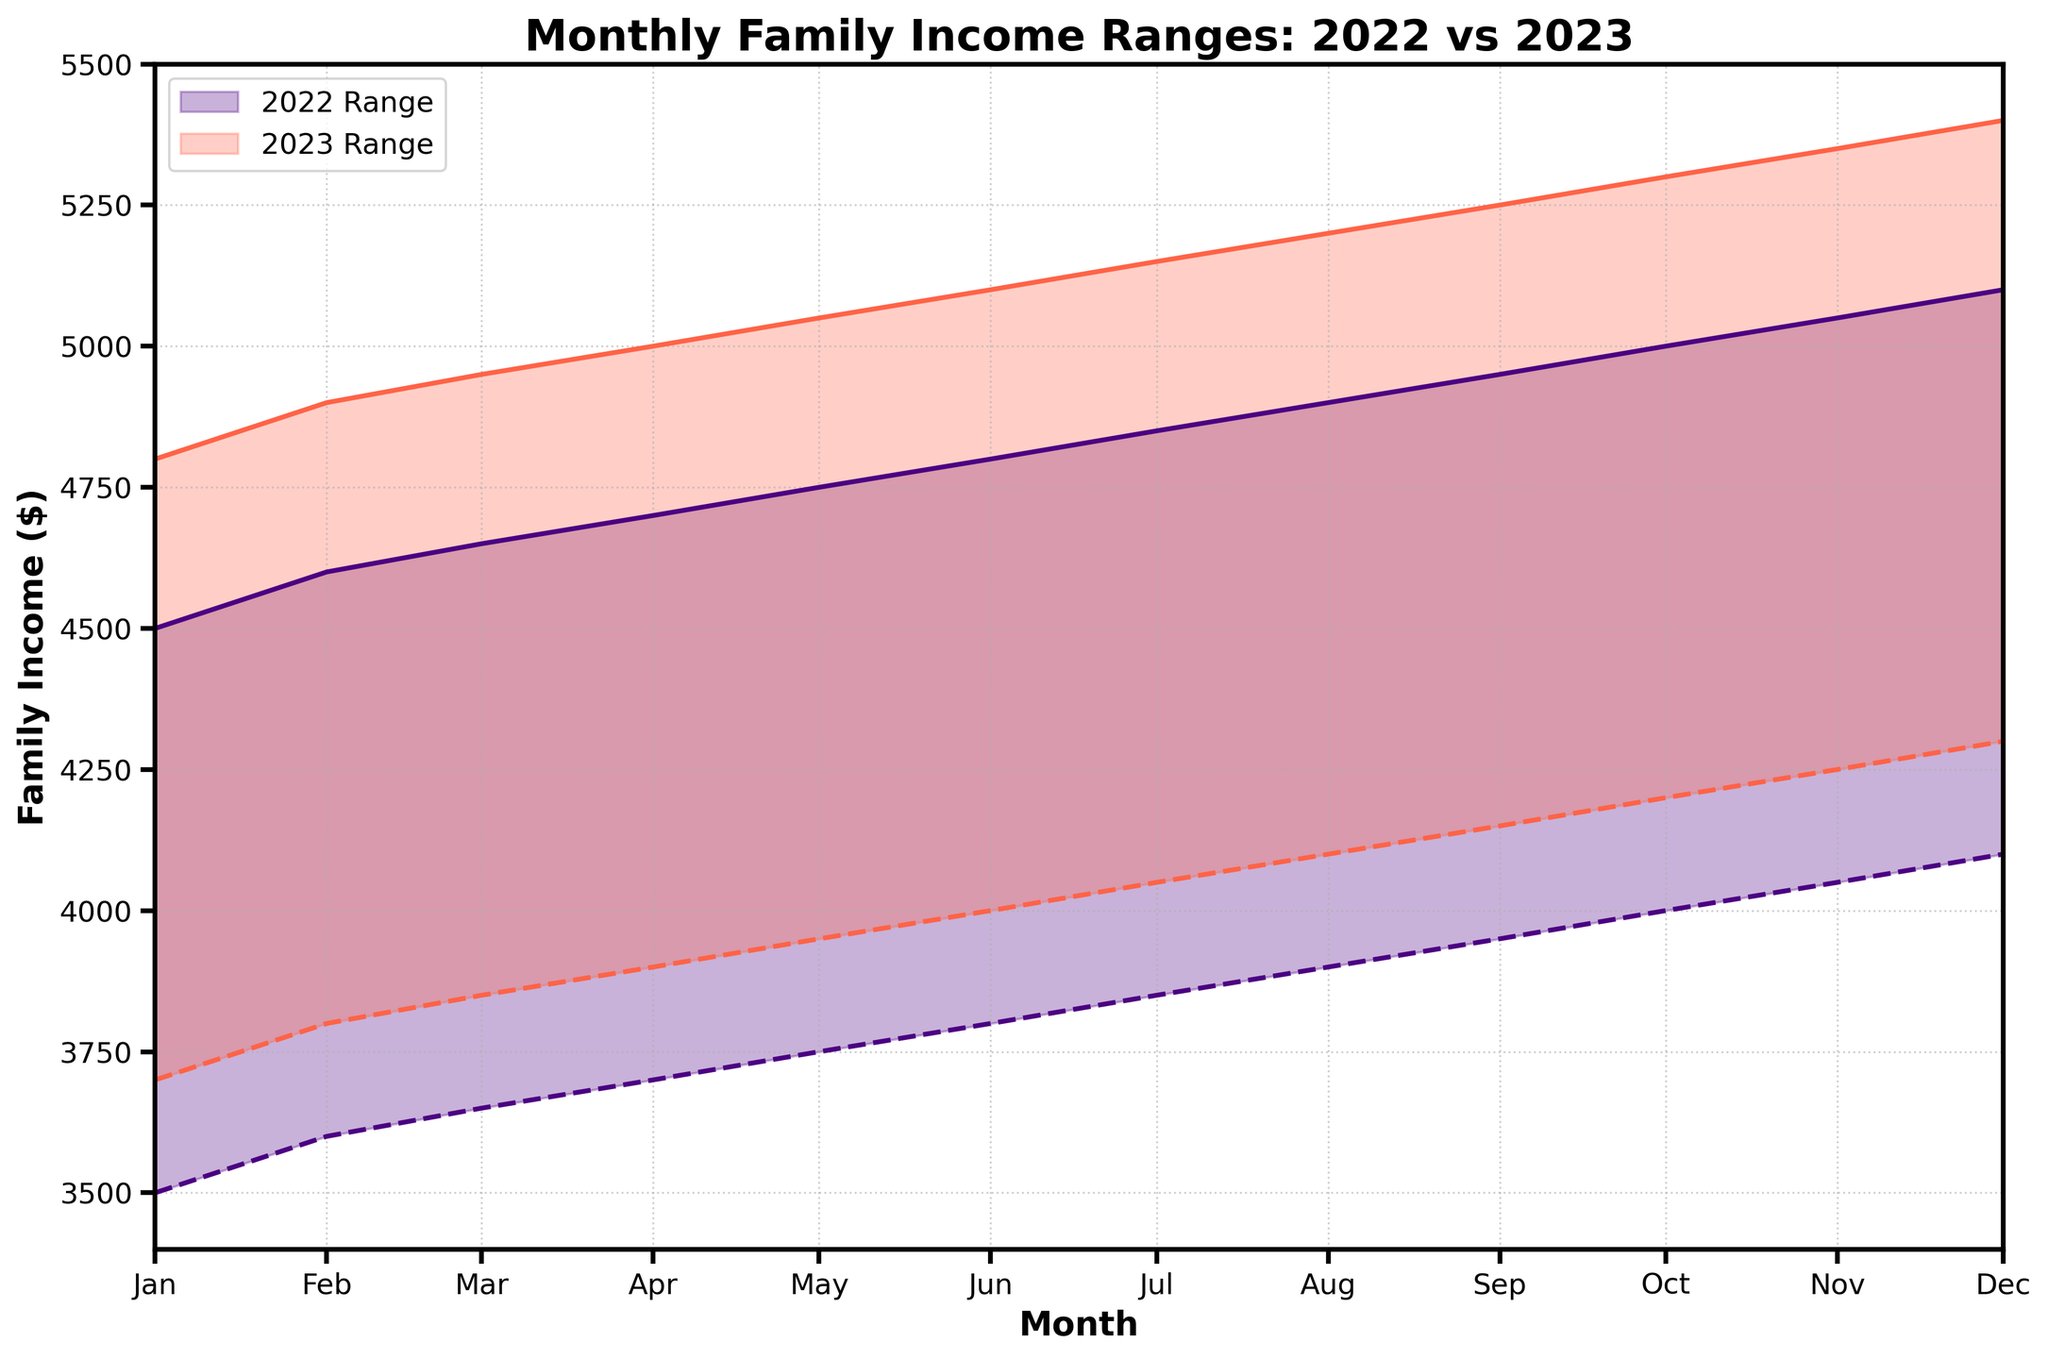What's the title of the chart? The title of the chart is written at the top and reads "Monthly Family Income Ranges: 2022 vs 2023".
Answer: Monthly Family Income Ranges: 2022 vs 2023 Which year shows a higher upper income range in December? From the chart, the Upper Income in December for 2022 is represented by one color (let's say indigo), and for 2023 is represented by another color (let's say tomato). The upper income for December 2023 is higher at $5400 compared to $5100 in 2022.
Answer: 2023 What is the difference in the lower income range between January 2022 and January 2023? In January 2022, the lower income is $3500. In January 2023, the lower income is $3700. The difference is $3700 - $3500 = $200.
Answer: $200 In which month is the gap between the upper income and lower income the largest for 2023? To determine the month with the largest gap, we need to look at the difference between the upper and lower income each month in 2023. By visually inspecting the data points, the gap is consistently $1100 for every month in 2023.
Answer: All months How does the slope of the lower income range compare between 2022 and 2023? The slope is calculated by the increase in income per month. In both 2022 and 2023, the lower income increase is consistent $50 per month. Thus, the slope for both years is similar. Visual inspection also confirms this steady increase.
Answer: Similar Which year experienced a steeper increase in upper income range across the months? To determine the steeper increase, observe the increment in upper income over the months. Both 2022 and 2023 have upper incomes increasing by $50 each month, indicating they have an equivalent rate of increase.
Answer: Neither, both are equal Is there any month where the income range overlaps between 2022 and 2023? To check for overlap, compare the income ranges for each month visually. There is no overlap because the lower income for 2023 is always higher than the upper income for 2022.
Answer: No Which month in 2022 had the highest upper income? By looking at the upper boundary of the income range for 2022, December has the highest upper income at $5100.
Answer: December What's the difference between the highest upper income in 2022 and 2023? The highest upper income in 2022 is $5100, and for 2023 it is $5400. The difference is $5400 - $5100 = $300.
Answer: $300 How does the income range width (upper minus lower) for November 2022 compare with November 2023? For November 2022, the income range is from $4050 to $5050, giving a width of $5050 - $4050 = $1000. For November 2023, it is from $4250 to $5350, giving a width of $5350 - $4250 = $1100. The range for November 2023 is wider by $100.
Answer: 2023 is wider by $100 